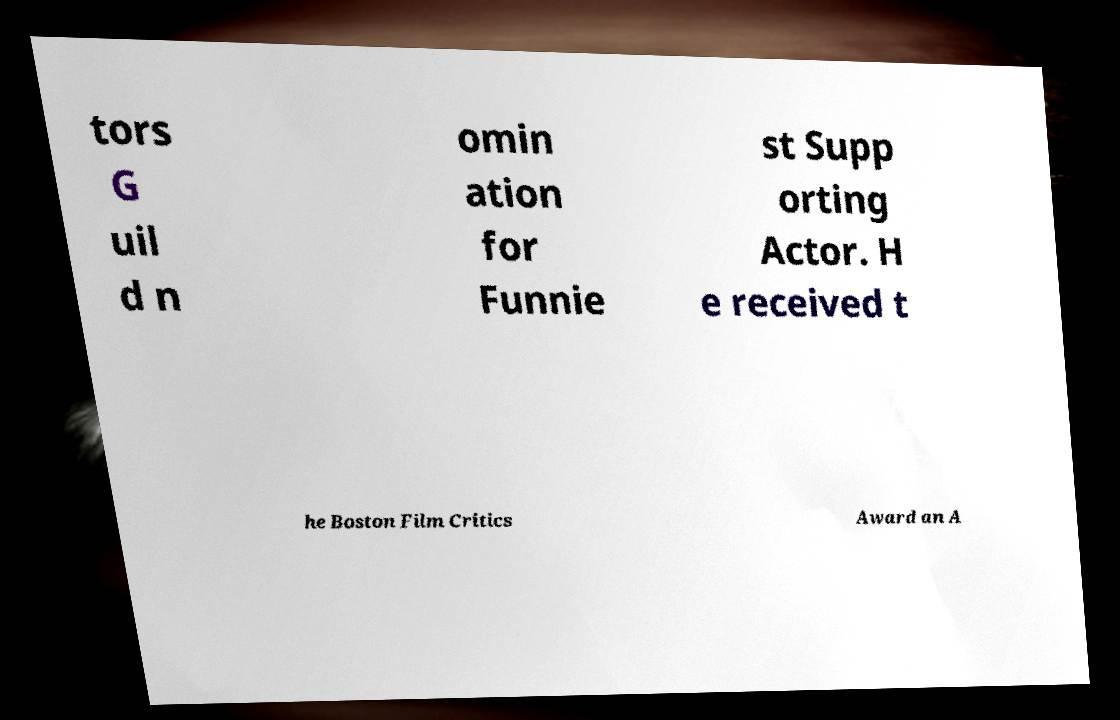For documentation purposes, I need the text within this image transcribed. Could you provide that? tors G uil d n omin ation for Funnie st Supp orting Actor. H e received t he Boston Film Critics Award an A 